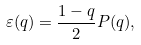<formula> <loc_0><loc_0><loc_500><loc_500>\varepsilon ( q ) = \frac { 1 - q } { 2 } P ( q ) ,</formula> 